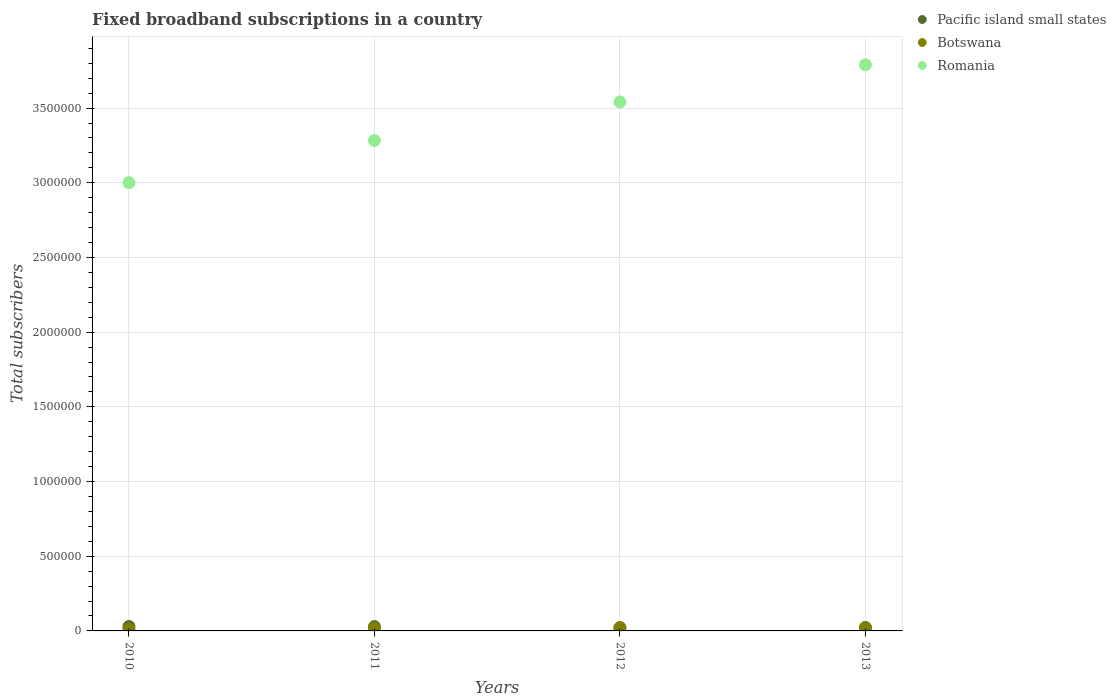What is the number of broadband subscriptions in Romania in 2013?
Ensure brevity in your answer.  3.79e+06. Across all years, what is the maximum number of broadband subscriptions in Pacific island small states?
Ensure brevity in your answer.  2.99e+04. Across all years, what is the minimum number of broadband subscriptions in Pacific island small states?
Ensure brevity in your answer.  2.10e+04. What is the total number of broadband subscriptions in Botswana in the graph?
Provide a succinct answer. 7.49e+04. What is the difference between the number of broadband subscriptions in Romania in 2010 and that in 2012?
Offer a terse response. -5.41e+05. What is the difference between the number of broadband subscriptions in Pacific island small states in 2010 and the number of broadband subscriptions in Botswana in 2012?
Make the answer very short. 7659. What is the average number of broadband subscriptions in Botswana per year?
Make the answer very short. 1.87e+04. In the year 2010, what is the difference between the number of broadband subscriptions in Romania and number of broadband subscriptions in Botswana?
Keep it short and to the point. 2.99e+06. In how many years, is the number of broadband subscriptions in Romania greater than 1600000?
Your answer should be very brief. 4. What is the ratio of the number of broadband subscriptions in Pacific island small states in 2010 to that in 2012?
Your answer should be compact. 1.42. What is the difference between the highest and the second highest number of broadband subscriptions in Botswana?
Your answer should be very brief. 646. What is the difference between the highest and the lowest number of broadband subscriptions in Pacific island small states?
Make the answer very short. 8905. In how many years, is the number of broadband subscriptions in Pacific island small states greater than the average number of broadband subscriptions in Pacific island small states taken over all years?
Ensure brevity in your answer.  2. Is the sum of the number of broadband subscriptions in Botswana in 2012 and 2013 greater than the maximum number of broadband subscriptions in Pacific island small states across all years?
Provide a succinct answer. Yes. Does the number of broadband subscriptions in Pacific island small states monotonically increase over the years?
Provide a short and direct response. No. Is the number of broadband subscriptions in Romania strictly less than the number of broadband subscriptions in Botswana over the years?
Offer a terse response. No. How many dotlines are there?
Provide a succinct answer. 3. Does the graph contain grids?
Make the answer very short. Yes. How many legend labels are there?
Ensure brevity in your answer.  3. How are the legend labels stacked?
Ensure brevity in your answer.  Vertical. What is the title of the graph?
Ensure brevity in your answer.  Fixed broadband subscriptions in a country. Does "Portugal" appear as one of the legend labels in the graph?
Make the answer very short. No. What is the label or title of the Y-axis?
Your response must be concise. Total subscribers. What is the Total subscribers in Pacific island small states in 2010?
Your answer should be compact. 2.99e+04. What is the Total subscribers in Botswana in 2010?
Your response must be concise. 1.20e+04. What is the Total subscribers in Romania in 2010?
Your answer should be compact. 3.00e+06. What is the Total subscribers of Pacific island small states in 2011?
Provide a short and direct response. 2.92e+04. What is the Total subscribers in Botswana in 2011?
Offer a very short reply. 1.91e+04. What is the Total subscribers in Romania in 2011?
Make the answer very short. 3.28e+06. What is the Total subscribers in Pacific island small states in 2012?
Ensure brevity in your answer.  2.10e+04. What is the Total subscribers in Botswana in 2012?
Provide a succinct answer. 2.22e+04. What is the Total subscribers of Romania in 2012?
Your answer should be compact. 3.54e+06. What is the Total subscribers of Pacific island small states in 2013?
Make the answer very short. 2.30e+04. What is the Total subscribers in Botswana in 2013?
Your answer should be very brief. 2.16e+04. What is the Total subscribers in Romania in 2013?
Keep it short and to the point. 3.79e+06. Across all years, what is the maximum Total subscribers in Pacific island small states?
Make the answer very short. 2.99e+04. Across all years, what is the maximum Total subscribers of Botswana?
Provide a succinct answer. 2.22e+04. Across all years, what is the maximum Total subscribers in Romania?
Offer a terse response. 3.79e+06. Across all years, what is the minimum Total subscribers of Pacific island small states?
Your response must be concise. 2.10e+04. Across all years, what is the minimum Total subscribers of Botswana?
Give a very brief answer. 1.20e+04. Across all years, what is the minimum Total subscribers of Romania?
Provide a succinct answer. 3.00e+06. What is the total Total subscribers of Pacific island small states in the graph?
Offer a terse response. 1.03e+05. What is the total Total subscribers of Botswana in the graph?
Provide a short and direct response. 7.49e+04. What is the total Total subscribers of Romania in the graph?
Keep it short and to the point. 1.36e+07. What is the difference between the Total subscribers of Pacific island small states in 2010 and that in 2011?
Provide a succinct answer. 690. What is the difference between the Total subscribers in Botswana in 2010 and that in 2011?
Offer a very short reply. -7147. What is the difference between the Total subscribers of Romania in 2010 and that in 2011?
Give a very brief answer. -2.83e+05. What is the difference between the Total subscribers in Pacific island small states in 2010 and that in 2012?
Your response must be concise. 8905. What is the difference between the Total subscribers in Botswana in 2010 and that in 2012?
Keep it short and to the point. -1.03e+04. What is the difference between the Total subscribers in Romania in 2010 and that in 2012?
Your answer should be compact. -5.41e+05. What is the difference between the Total subscribers of Pacific island small states in 2010 and that in 2013?
Your answer should be very brief. 6884. What is the difference between the Total subscribers in Botswana in 2010 and that in 2013?
Give a very brief answer. -9612. What is the difference between the Total subscribers in Romania in 2010 and that in 2013?
Provide a short and direct response. -7.89e+05. What is the difference between the Total subscribers in Pacific island small states in 2011 and that in 2012?
Ensure brevity in your answer.  8215. What is the difference between the Total subscribers in Botswana in 2011 and that in 2012?
Make the answer very short. -3111. What is the difference between the Total subscribers in Romania in 2011 and that in 2012?
Your response must be concise. -2.58e+05. What is the difference between the Total subscribers in Pacific island small states in 2011 and that in 2013?
Your answer should be very brief. 6194. What is the difference between the Total subscribers in Botswana in 2011 and that in 2013?
Give a very brief answer. -2465. What is the difference between the Total subscribers in Romania in 2011 and that in 2013?
Offer a very short reply. -5.07e+05. What is the difference between the Total subscribers of Pacific island small states in 2012 and that in 2013?
Your answer should be compact. -2021. What is the difference between the Total subscribers in Botswana in 2012 and that in 2013?
Your answer should be very brief. 646. What is the difference between the Total subscribers of Romania in 2012 and that in 2013?
Offer a terse response. -2.49e+05. What is the difference between the Total subscribers in Pacific island small states in 2010 and the Total subscribers in Botswana in 2011?
Your response must be concise. 1.08e+04. What is the difference between the Total subscribers of Pacific island small states in 2010 and the Total subscribers of Romania in 2011?
Offer a very short reply. -3.25e+06. What is the difference between the Total subscribers in Botswana in 2010 and the Total subscribers in Romania in 2011?
Offer a very short reply. -3.27e+06. What is the difference between the Total subscribers in Pacific island small states in 2010 and the Total subscribers in Botswana in 2012?
Your answer should be very brief. 7659. What is the difference between the Total subscribers of Pacific island small states in 2010 and the Total subscribers of Romania in 2012?
Your response must be concise. -3.51e+06. What is the difference between the Total subscribers of Botswana in 2010 and the Total subscribers of Romania in 2012?
Your answer should be compact. -3.53e+06. What is the difference between the Total subscribers in Pacific island small states in 2010 and the Total subscribers in Botswana in 2013?
Offer a terse response. 8305. What is the difference between the Total subscribers of Pacific island small states in 2010 and the Total subscribers of Romania in 2013?
Provide a short and direct response. -3.76e+06. What is the difference between the Total subscribers in Botswana in 2010 and the Total subscribers in Romania in 2013?
Provide a short and direct response. -3.78e+06. What is the difference between the Total subscribers of Pacific island small states in 2011 and the Total subscribers of Botswana in 2012?
Provide a short and direct response. 6969. What is the difference between the Total subscribers of Pacific island small states in 2011 and the Total subscribers of Romania in 2012?
Provide a succinct answer. -3.51e+06. What is the difference between the Total subscribers of Botswana in 2011 and the Total subscribers of Romania in 2012?
Offer a terse response. -3.52e+06. What is the difference between the Total subscribers of Pacific island small states in 2011 and the Total subscribers of Botswana in 2013?
Provide a succinct answer. 7615. What is the difference between the Total subscribers of Pacific island small states in 2011 and the Total subscribers of Romania in 2013?
Your answer should be very brief. -3.76e+06. What is the difference between the Total subscribers of Botswana in 2011 and the Total subscribers of Romania in 2013?
Your response must be concise. -3.77e+06. What is the difference between the Total subscribers of Pacific island small states in 2012 and the Total subscribers of Botswana in 2013?
Your answer should be compact. -600. What is the difference between the Total subscribers in Pacific island small states in 2012 and the Total subscribers in Romania in 2013?
Your response must be concise. -3.77e+06. What is the difference between the Total subscribers in Botswana in 2012 and the Total subscribers in Romania in 2013?
Offer a very short reply. -3.77e+06. What is the average Total subscribers in Pacific island small states per year?
Provide a short and direct response. 2.58e+04. What is the average Total subscribers in Botswana per year?
Provide a succinct answer. 1.87e+04. What is the average Total subscribers in Romania per year?
Keep it short and to the point. 3.40e+06. In the year 2010, what is the difference between the Total subscribers in Pacific island small states and Total subscribers in Botswana?
Provide a short and direct response. 1.79e+04. In the year 2010, what is the difference between the Total subscribers of Pacific island small states and Total subscribers of Romania?
Offer a terse response. -2.97e+06. In the year 2010, what is the difference between the Total subscribers in Botswana and Total subscribers in Romania?
Keep it short and to the point. -2.99e+06. In the year 2011, what is the difference between the Total subscribers in Pacific island small states and Total subscribers in Botswana?
Keep it short and to the point. 1.01e+04. In the year 2011, what is the difference between the Total subscribers in Pacific island small states and Total subscribers in Romania?
Provide a succinct answer. -3.25e+06. In the year 2011, what is the difference between the Total subscribers of Botswana and Total subscribers of Romania?
Offer a terse response. -3.26e+06. In the year 2012, what is the difference between the Total subscribers of Pacific island small states and Total subscribers of Botswana?
Your answer should be very brief. -1246. In the year 2012, what is the difference between the Total subscribers in Pacific island small states and Total subscribers in Romania?
Your response must be concise. -3.52e+06. In the year 2012, what is the difference between the Total subscribers of Botswana and Total subscribers of Romania?
Keep it short and to the point. -3.52e+06. In the year 2013, what is the difference between the Total subscribers of Pacific island small states and Total subscribers of Botswana?
Your answer should be very brief. 1421. In the year 2013, what is the difference between the Total subscribers in Pacific island small states and Total subscribers in Romania?
Your response must be concise. -3.77e+06. In the year 2013, what is the difference between the Total subscribers of Botswana and Total subscribers of Romania?
Your answer should be very brief. -3.77e+06. What is the ratio of the Total subscribers in Pacific island small states in 2010 to that in 2011?
Your response must be concise. 1.02. What is the ratio of the Total subscribers in Botswana in 2010 to that in 2011?
Your answer should be compact. 0.63. What is the ratio of the Total subscribers of Romania in 2010 to that in 2011?
Offer a very short reply. 0.91. What is the ratio of the Total subscribers in Pacific island small states in 2010 to that in 2012?
Provide a succinct answer. 1.42. What is the ratio of the Total subscribers of Botswana in 2010 to that in 2012?
Your response must be concise. 0.54. What is the ratio of the Total subscribers in Romania in 2010 to that in 2012?
Provide a succinct answer. 0.85. What is the ratio of the Total subscribers in Pacific island small states in 2010 to that in 2013?
Offer a very short reply. 1.3. What is the ratio of the Total subscribers of Botswana in 2010 to that in 2013?
Your answer should be very brief. 0.55. What is the ratio of the Total subscribers in Romania in 2010 to that in 2013?
Keep it short and to the point. 0.79. What is the ratio of the Total subscribers of Pacific island small states in 2011 to that in 2012?
Keep it short and to the point. 1.39. What is the ratio of the Total subscribers of Botswana in 2011 to that in 2012?
Keep it short and to the point. 0.86. What is the ratio of the Total subscribers of Romania in 2011 to that in 2012?
Ensure brevity in your answer.  0.93. What is the ratio of the Total subscribers of Pacific island small states in 2011 to that in 2013?
Your answer should be very brief. 1.27. What is the ratio of the Total subscribers in Botswana in 2011 to that in 2013?
Offer a very short reply. 0.89. What is the ratio of the Total subscribers in Romania in 2011 to that in 2013?
Give a very brief answer. 0.87. What is the ratio of the Total subscribers of Pacific island small states in 2012 to that in 2013?
Provide a succinct answer. 0.91. What is the ratio of the Total subscribers in Botswana in 2012 to that in 2013?
Offer a very short reply. 1.03. What is the ratio of the Total subscribers of Romania in 2012 to that in 2013?
Provide a short and direct response. 0.93. What is the difference between the highest and the second highest Total subscribers of Pacific island small states?
Your answer should be compact. 690. What is the difference between the highest and the second highest Total subscribers in Botswana?
Give a very brief answer. 646. What is the difference between the highest and the second highest Total subscribers in Romania?
Offer a terse response. 2.49e+05. What is the difference between the highest and the lowest Total subscribers of Pacific island small states?
Your response must be concise. 8905. What is the difference between the highest and the lowest Total subscribers of Botswana?
Offer a very short reply. 1.03e+04. What is the difference between the highest and the lowest Total subscribers of Romania?
Give a very brief answer. 7.89e+05. 